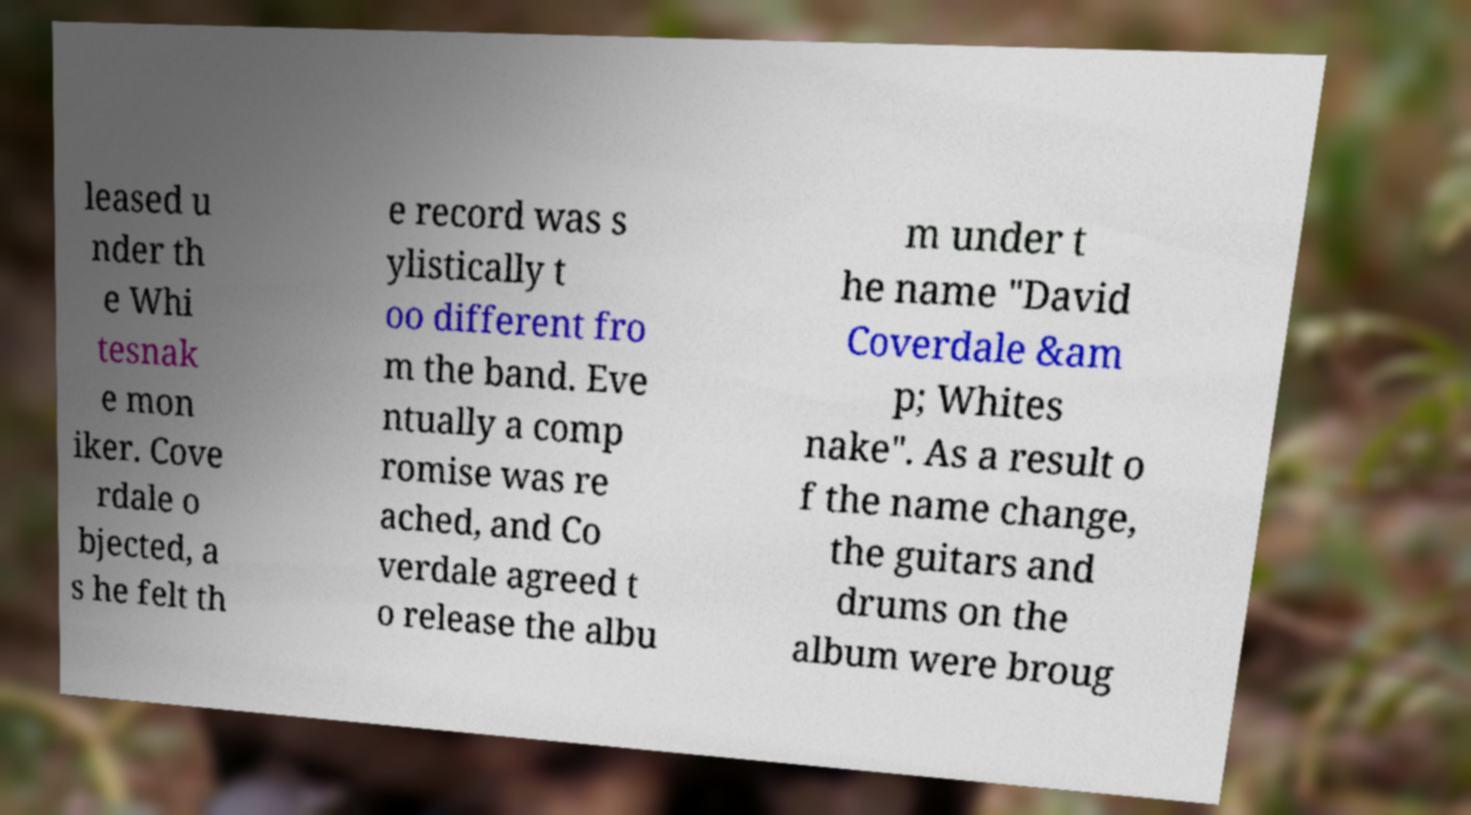Could you assist in decoding the text presented in this image and type it out clearly? leased u nder th e Whi tesnak e mon iker. Cove rdale o bjected, a s he felt th e record was s ylistically t oo different fro m the band. Eve ntually a comp romise was re ached, and Co verdale agreed t o release the albu m under t he name "David Coverdale &am p; Whites nake". As a result o f the name change, the guitars and drums on the album were broug 